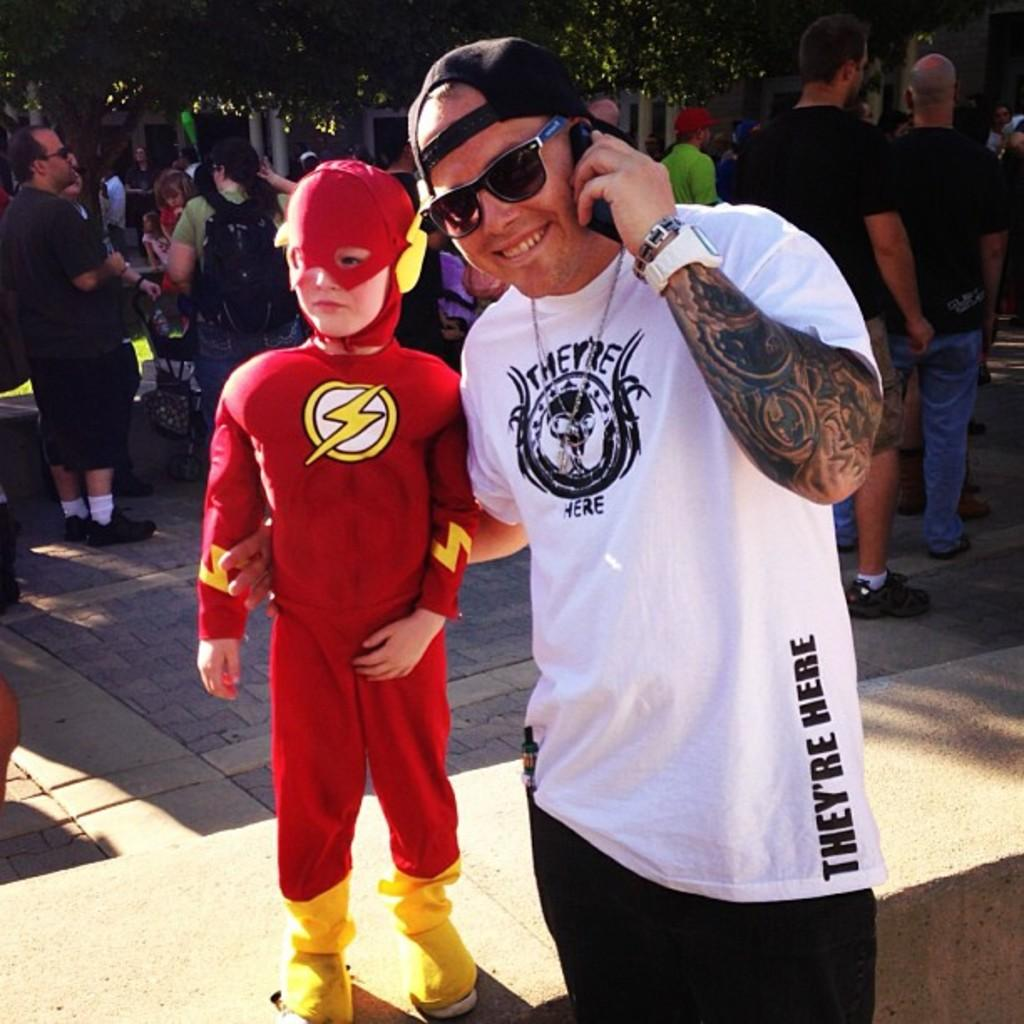How many people are present in the image? There are two persons standing in the image. What is the attire of one of the persons? One person is wearing a fancy dress. Can you describe the group of people in the image? There is a group of people standing in the image. What can be seen in the background of the image? There are trees in the background of the image. What type of cake is being served at the religious ceremony in the image? There is no cake or religious ceremony present in the image. What degree does the person in the fancy dress hold? There is no indication of a degree or any educational qualifications in the image. 